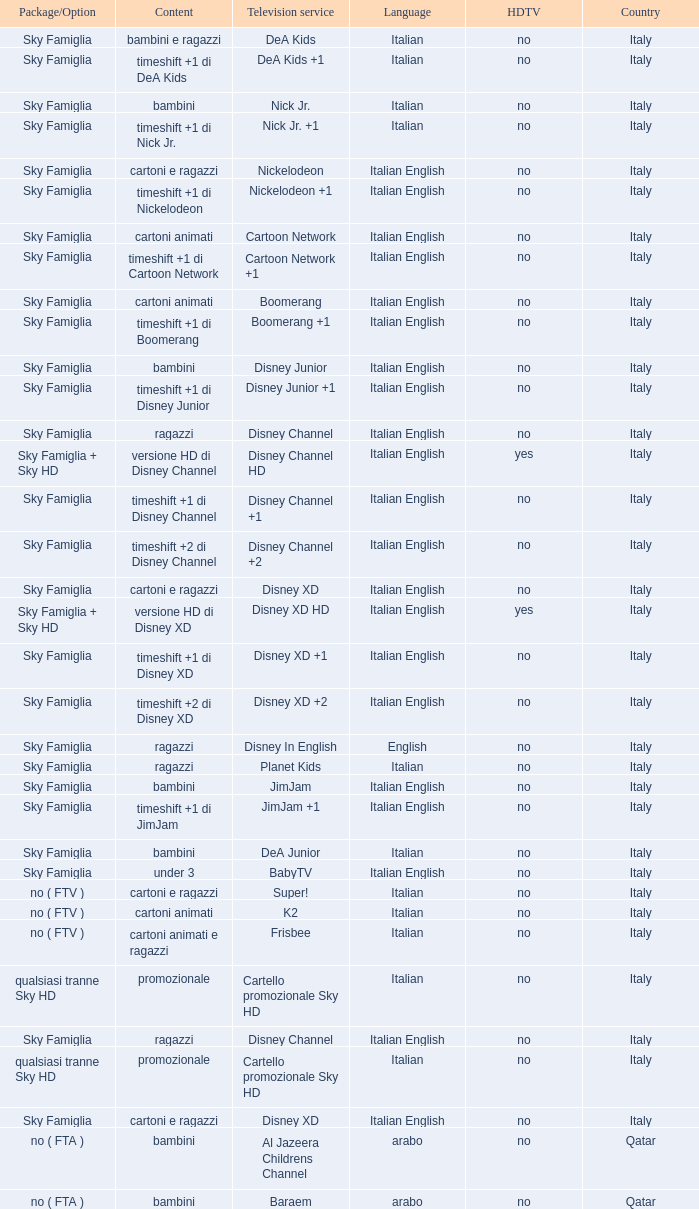What is the Country when the language is italian english, and the television service is disney xd +1? Italy. 